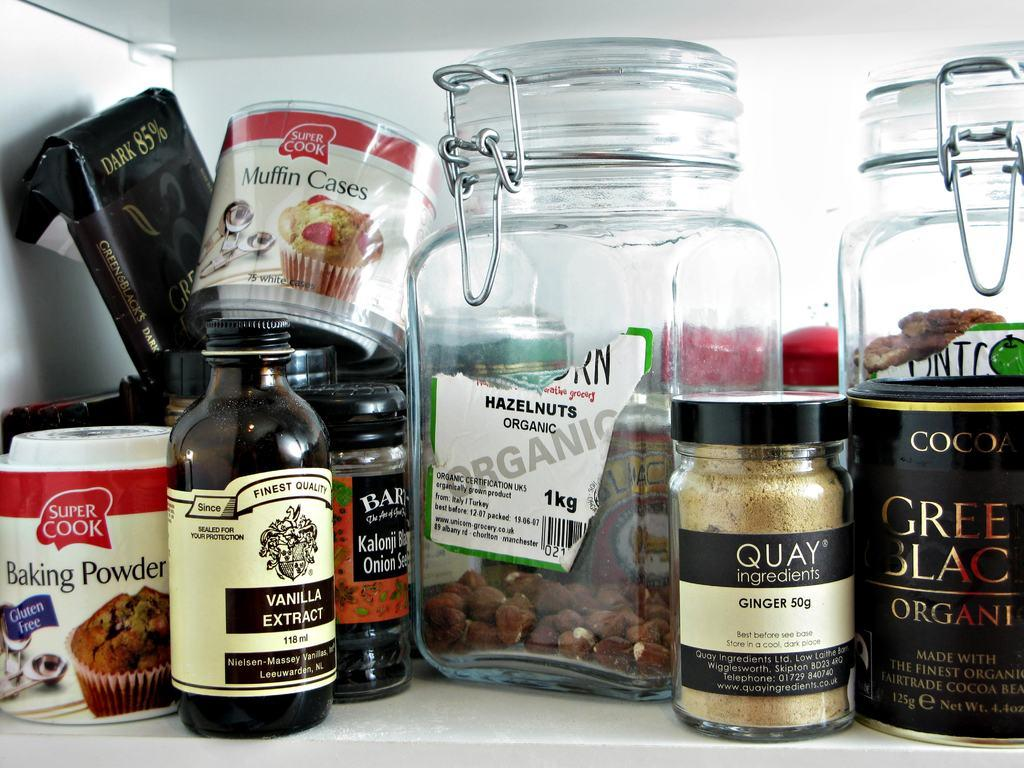What types of containers are visible in the image? There are bottles and boxes in the image. Can you describe the contents of the containers? The contents of the containers are not visible in the image. What is the primary purpose of these containers? The primary purpose of these containers is likely for storage or transportation. What type of salt is being discussed by the doctor in the image? There is no doctor or discussion about salt present in the image. 